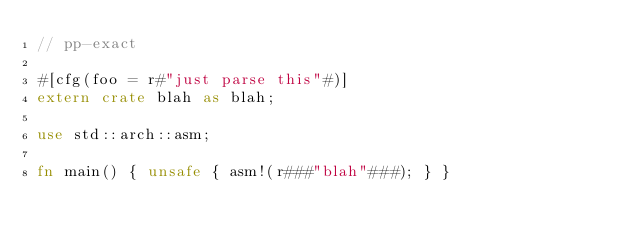<code> <loc_0><loc_0><loc_500><loc_500><_Rust_>// pp-exact

#[cfg(foo = r#"just parse this"#)]
extern crate blah as blah;

use std::arch::asm;

fn main() { unsafe { asm!(r###"blah"###); } }
</code> 